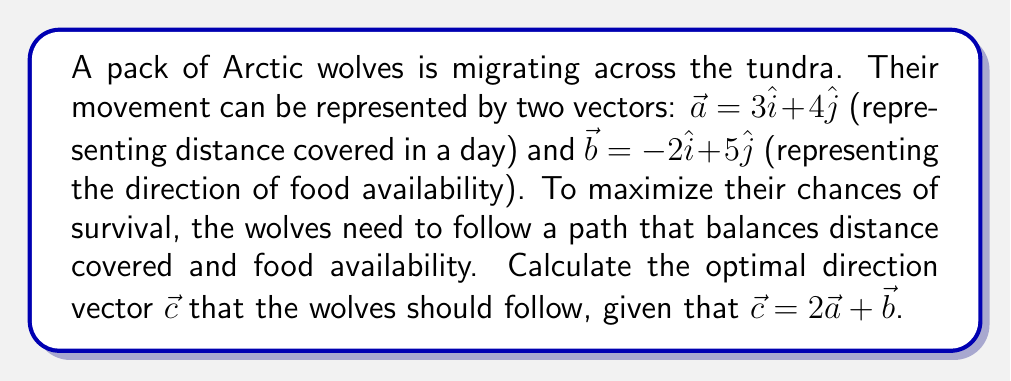Show me your answer to this math problem. To solve this problem, we'll follow these steps:

1. Identify the given vectors:
   $\vec{a} = 3\hat{i} + 4\hat{j}$
   $\vec{b} = -2\hat{i} + 5\hat{j}$

2. Use the given equation to calculate $\vec{c}$:
   $\vec{c} = 2\vec{a} + \vec{b}$

3. Substitute the values of $\vec{a}$ and $\vec{b}$:
   $\vec{c} = 2(3\hat{i} + 4\hat{j}) + (-2\hat{i} + 5\hat{j})$

4. Distribute the scalar 2:
   $\vec{c} = (6\hat{i} + 8\hat{j}) + (-2\hat{i} + 5\hat{j})$

5. Add the components:
   $\vec{c} = (6\hat{i} - 2\hat{i}) + (8\hat{j} + 5\hat{j})$
   $\vec{c} = 4\hat{i} + 13\hat{j}$

Therefore, the optimal direction vector for the Arctic wolves' migration is $\vec{c} = 4\hat{i} + 13\hat{j}$.
Answer: $4\hat{i} + 13\hat{j}$ 